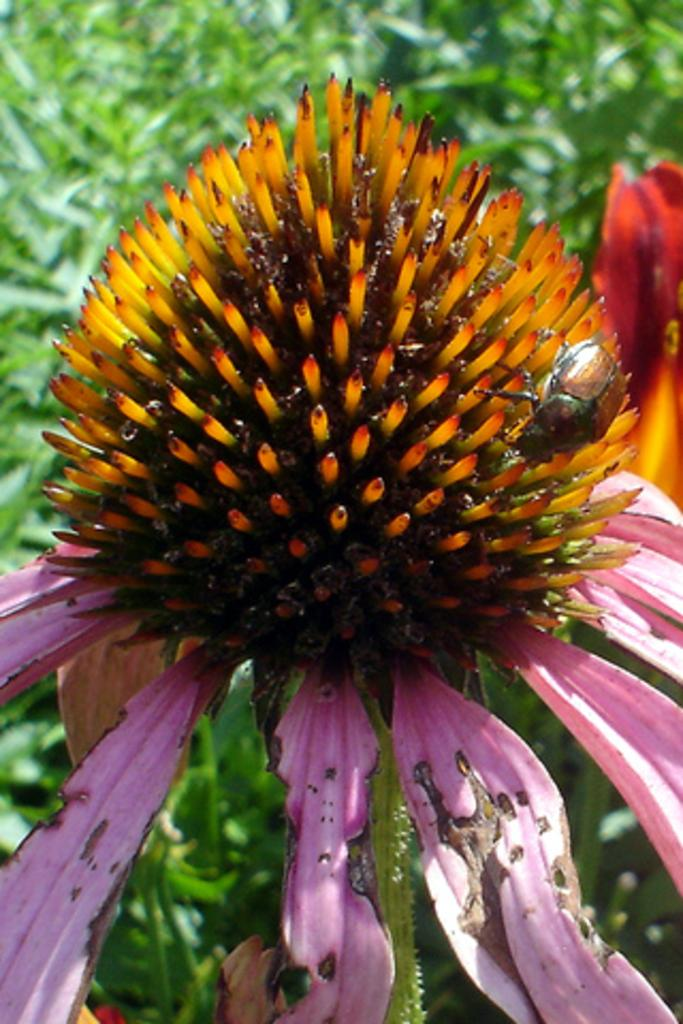What is the main subject of the image? There is a flower in the image. Where is the flower located? The flower is on a plant. What colors can be seen on the flower? The flower has orange and pink colors. What else can be seen in the background of the image? There are other plants visible in the background of the image. Can you tell me how many mint leaves are on the flower in the image? There is no mention of mint leaves in the image; the flower has orange and pink colors. 